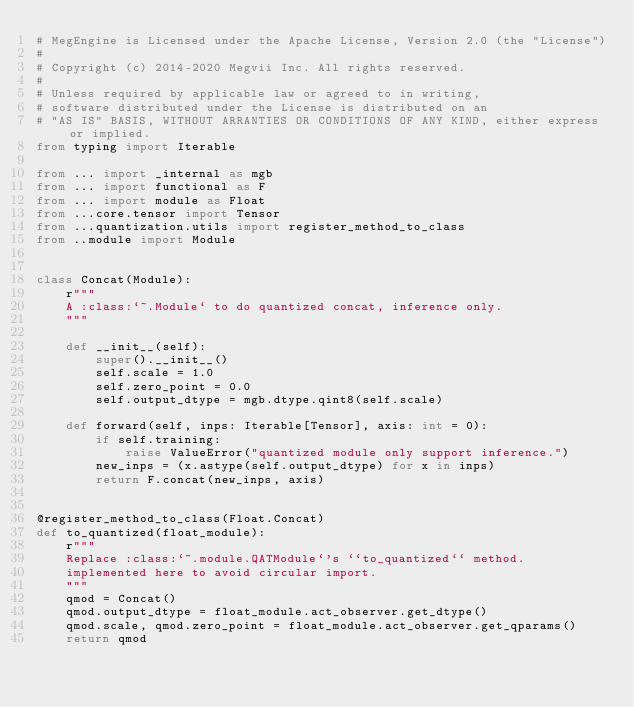Convert code to text. <code><loc_0><loc_0><loc_500><loc_500><_Python_># MegEngine is Licensed under the Apache License, Version 2.0 (the "License")
#
# Copyright (c) 2014-2020 Megvii Inc. All rights reserved.
#
# Unless required by applicable law or agreed to in writing,
# software distributed under the License is distributed on an
# "AS IS" BASIS, WITHOUT ARRANTIES OR CONDITIONS OF ANY KIND, either express or implied.
from typing import Iterable

from ... import _internal as mgb
from ... import functional as F
from ... import module as Float
from ...core.tensor import Tensor
from ...quantization.utils import register_method_to_class
from ..module import Module


class Concat(Module):
    r"""
    A :class:`~.Module` to do quantized concat, inference only.
    """

    def __init__(self):
        super().__init__()
        self.scale = 1.0
        self.zero_point = 0.0
        self.output_dtype = mgb.dtype.qint8(self.scale)

    def forward(self, inps: Iterable[Tensor], axis: int = 0):
        if self.training:
            raise ValueError("quantized module only support inference.")
        new_inps = (x.astype(self.output_dtype) for x in inps)
        return F.concat(new_inps, axis)


@register_method_to_class(Float.Concat)
def to_quantized(float_module):
    r"""
    Replace :class:`~.module.QATModule`'s ``to_quantized`` method.
    implemented here to avoid circular import.
    """
    qmod = Concat()
    qmod.output_dtype = float_module.act_observer.get_dtype()
    qmod.scale, qmod.zero_point = float_module.act_observer.get_qparams()
    return qmod
</code> 